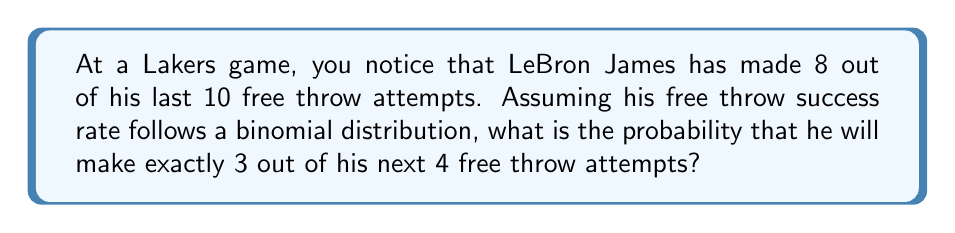Could you help me with this problem? To solve this problem, we'll use the binomial probability formula, given that LeBron's free throw attempts follow a binomial distribution.

1) First, we need to estimate LeBron's free throw success rate based on the given information:
   $p = \frac{8}{10} = 0.8$ or 80%

2) The binomial probability formula is:

   $$P(X = k) = \binom{n}{k} p^k (1-p)^{n-k}$$

   Where:
   $n$ = number of trials (4 free throw attempts)
   $k$ = number of successes (3 made free throws)
   $p$ = probability of success on each trial (0.8)

3) Let's substitute these values:

   $$P(X = 3) = \binom{4}{3} (0.8)^3 (1-0.8)^{4-3}$$

4) Calculate the binomial coefficient:
   
   $$\binom{4}{3} = \frac{4!}{3!(4-3)!} = \frac{4!}{3!1!} = 4$$

5) Now our equation looks like this:

   $$P(X = 3) = 4 \cdot (0.8)^3 \cdot (0.2)^1$$

6) Calculate the powers:

   $$P(X = 3) = 4 \cdot 0.512 \cdot 0.2$$

7) Multiply:

   $$P(X = 3) = 0.4096$$

Therefore, the probability of LeBron making exactly 3 out of his next 4 free throw attempts is approximately 0.4096 or 40.96%.
Answer: 0.4096 or 40.96% 